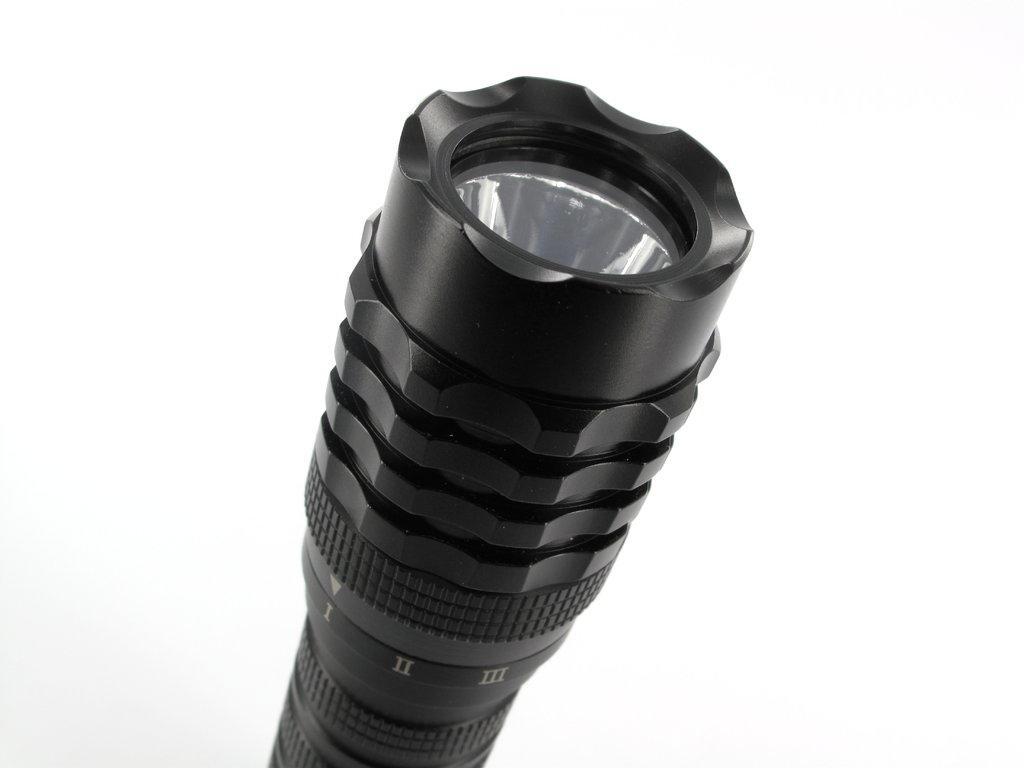How would you summarize this image in a sentence or two? In the image there is a black color torch light. 